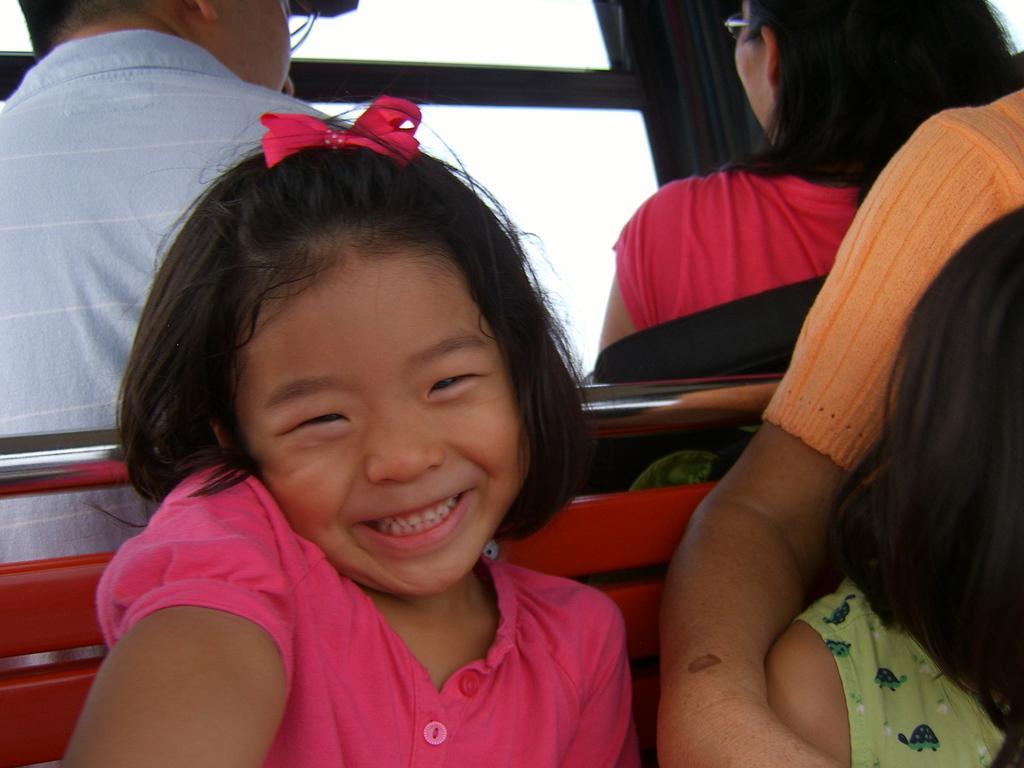Please provide a concise description of this image. In this image I see a girl who is smiling and I see that she is wearing pink top and I see that she is sitting and I see few people over here and I see the black color thing in the background and I see that it is white over here. 